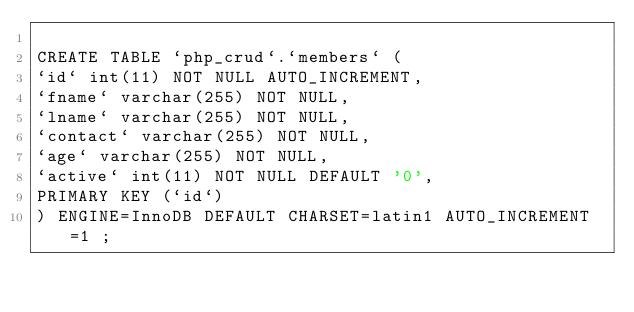<code> <loc_0><loc_0><loc_500><loc_500><_SQL_>
CREATE TABLE `php_crud`.`members` (
`id` int(11) NOT NULL AUTO_INCREMENT,
`fname` varchar(255) NOT NULL,
`lname` varchar(255) NOT NULL,
`contact` varchar(255) NOT NULL,
`age` varchar(255) NOT NULL,
`active` int(11) NOT NULL DEFAULT '0',
PRIMARY KEY (`id`)
) ENGINE=InnoDB DEFAULT CHARSET=latin1 AUTO_INCREMENT=1 ;

</code> 